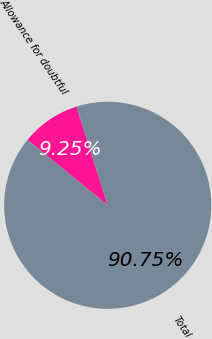Convert chart to OTSL. <chart><loc_0><loc_0><loc_500><loc_500><pie_chart><fcel>Allowance for doubtful<fcel>Total<nl><fcel>9.25%<fcel>90.75%<nl></chart> 